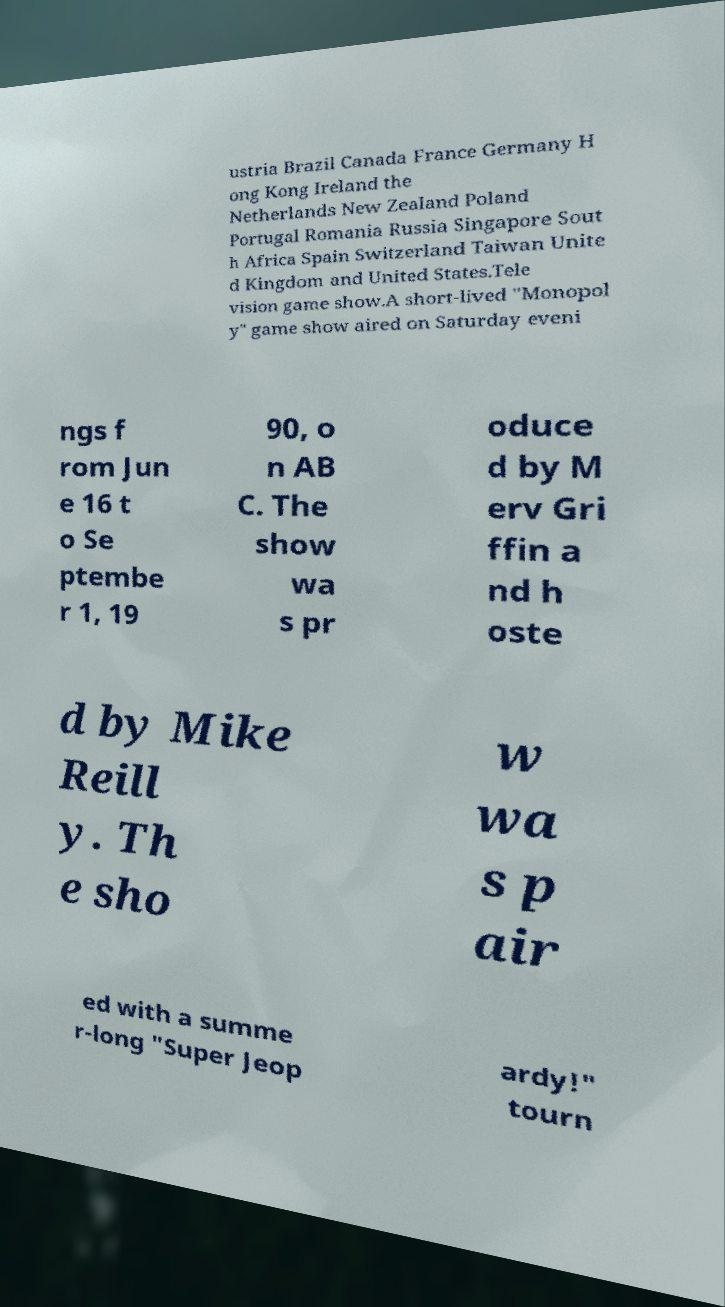Can you accurately transcribe the text from the provided image for me? ustria Brazil Canada France Germany H ong Kong Ireland the Netherlands New Zealand Poland Portugal Romania Russia Singapore Sout h Africa Spain Switzerland Taiwan Unite d Kingdom and United States.Tele vision game show.A short-lived "Monopol y" game show aired on Saturday eveni ngs f rom Jun e 16 t o Se ptembe r 1, 19 90, o n AB C. The show wa s pr oduce d by M erv Gri ffin a nd h oste d by Mike Reill y. Th e sho w wa s p air ed with a summe r-long "Super Jeop ardy!" tourn 